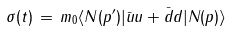<formula> <loc_0><loc_0><loc_500><loc_500>\sigma ( t ) \, = \, m _ { 0 } \langle N ( p ^ { \prime } ) | \bar { u } u + \bar { d } { d } | N ( p ) \rangle</formula> 